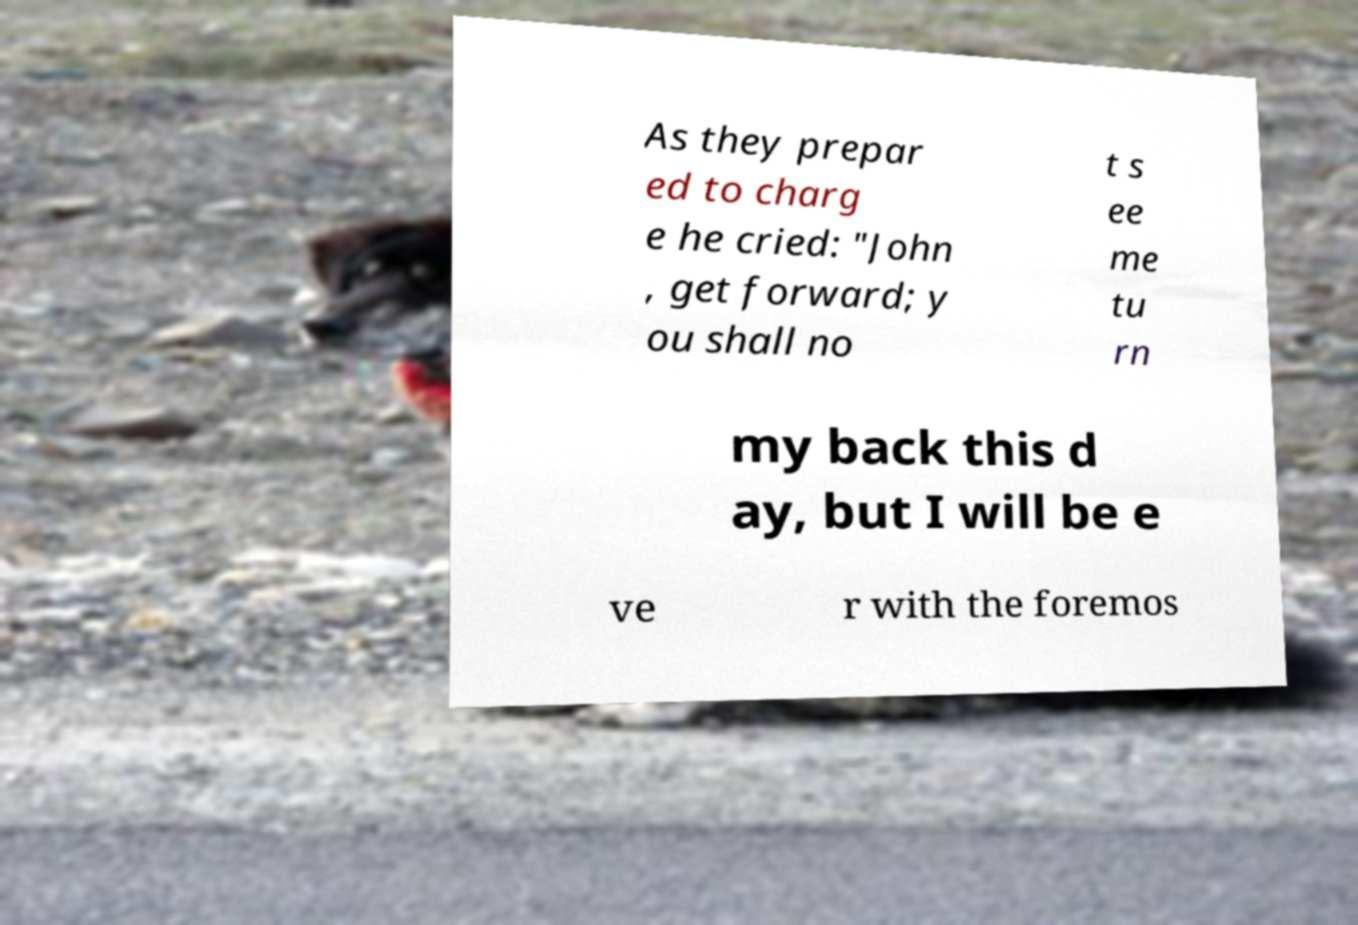What messages or text are displayed in this image? I need them in a readable, typed format. As they prepar ed to charg e he cried: "John , get forward; y ou shall no t s ee me tu rn my back this d ay, but I will be e ve r with the foremos 